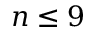<formula> <loc_0><loc_0><loc_500><loc_500>n \leq 9</formula> 